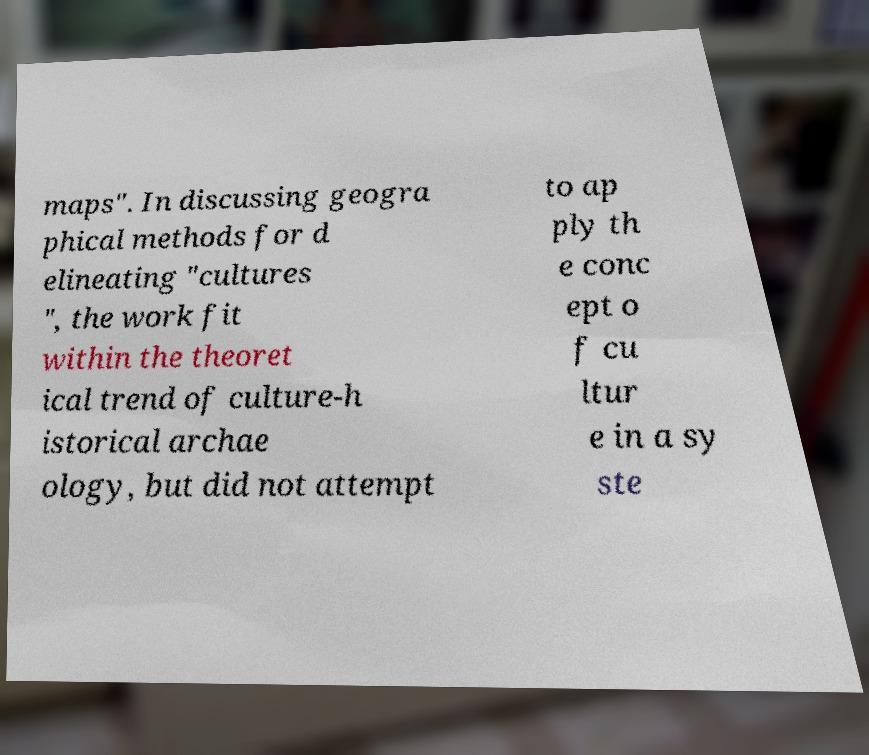Could you extract and type out the text from this image? maps". In discussing geogra phical methods for d elineating "cultures ", the work fit within the theoret ical trend of culture-h istorical archae ology, but did not attempt to ap ply th e conc ept o f cu ltur e in a sy ste 